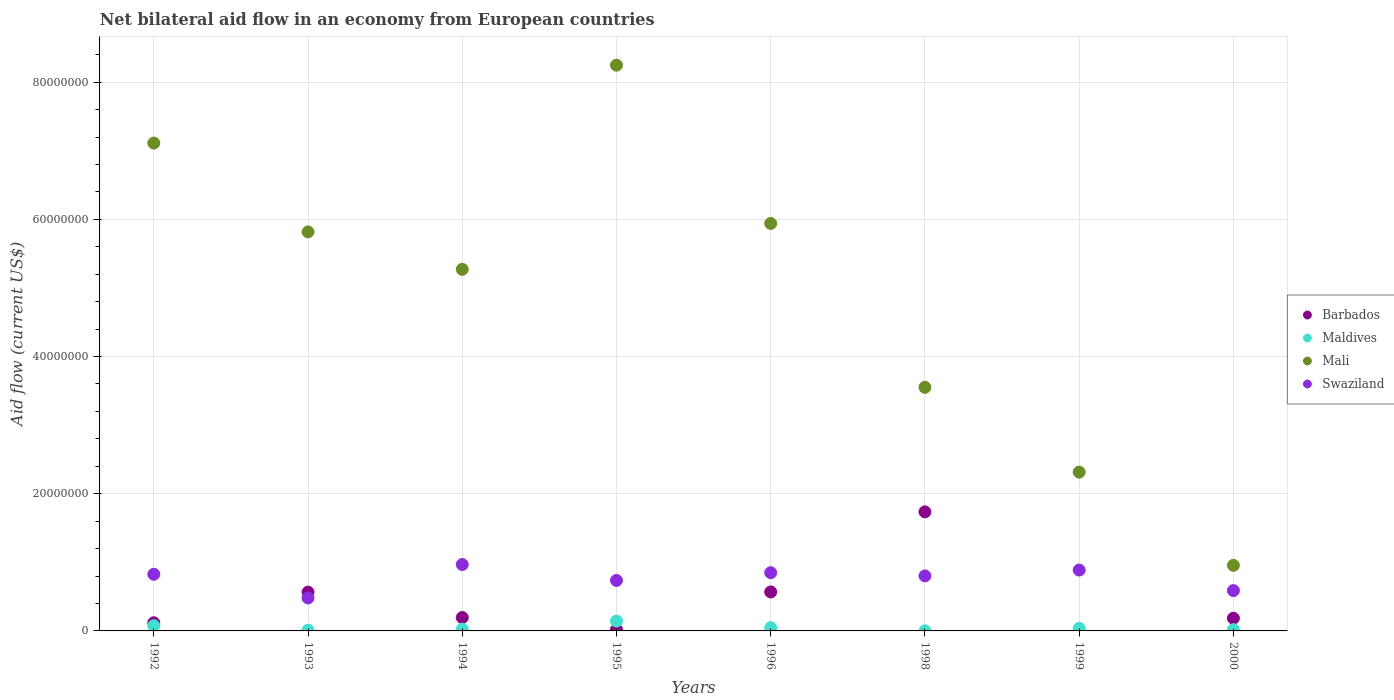How many different coloured dotlines are there?
Provide a succinct answer. 4. Is the number of dotlines equal to the number of legend labels?
Provide a succinct answer. No. What is the net bilateral aid flow in Maldives in 1995?
Offer a very short reply. 1.44e+06. Across all years, what is the maximum net bilateral aid flow in Mali?
Provide a succinct answer. 8.25e+07. Across all years, what is the minimum net bilateral aid flow in Mali?
Provide a succinct answer. 9.56e+06. In which year was the net bilateral aid flow in Maldives maximum?
Your response must be concise. 1995. What is the total net bilateral aid flow in Maldives in the graph?
Provide a succinct answer. 3.62e+06. What is the difference between the net bilateral aid flow in Swaziland in 1996 and that in 2000?
Offer a very short reply. 2.61e+06. What is the difference between the net bilateral aid flow in Mali in 1999 and the net bilateral aid flow in Barbados in 2000?
Ensure brevity in your answer.  2.13e+07. What is the average net bilateral aid flow in Swaziland per year?
Ensure brevity in your answer.  7.67e+06. In the year 1998, what is the difference between the net bilateral aid flow in Mali and net bilateral aid flow in Maldives?
Your answer should be compact. 3.55e+07. In how many years, is the net bilateral aid flow in Maldives greater than 72000000 US$?
Make the answer very short. 0. What is the ratio of the net bilateral aid flow in Swaziland in 1996 to that in 1998?
Ensure brevity in your answer.  1.06. Is the net bilateral aid flow in Swaziland in 1994 less than that in 2000?
Provide a short and direct response. No. What is the difference between the highest and the second highest net bilateral aid flow in Barbados?
Your answer should be very brief. 1.17e+07. What is the difference between the highest and the lowest net bilateral aid flow in Barbados?
Give a very brief answer. 1.74e+07. Is the sum of the net bilateral aid flow in Swaziland in 1998 and 2000 greater than the maximum net bilateral aid flow in Maldives across all years?
Keep it short and to the point. Yes. Is it the case that in every year, the sum of the net bilateral aid flow in Swaziland and net bilateral aid flow in Maldives  is greater than the net bilateral aid flow in Mali?
Provide a succinct answer. No. Does the net bilateral aid flow in Swaziland monotonically increase over the years?
Keep it short and to the point. No. Is the net bilateral aid flow in Mali strictly greater than the net bilateral aid flow in Swaziland over the years?
Offer a terse response. Yes. How many dotlines are there?
Your answer should be very brief. 4. Does the graph contain any zero values?
Your answer should be compact. Yes. Does the graph contain grids?
Your answer should be very brief. Yes. Where does the legend appear in the graph?
Offer a terse response. Center right. How many legend labels are there?
Ensure brevity in your answer.  4. How are the legend labels stacked?
Provide a succinct answer. Vertical. What is the title of the graph?
Your answer should be very brief. Net bilateral aid flow in an economy from European countries. What is the Aid flow (current US$) of Barbados in 1992?
Your response must be concise. 1.19e+06. What is the Aid flow (current US$) of Maldives in 1992?
Your response must be concise. 7.60e+05. What is the Aid flow (current US$) of Mali in 1992?
Give a very brief answer. 7.11e+07. What is the Aid flow (current US$) in Swaziland in 1992?
Offer a very short reply. 8.26e+06. What is the Aid flow (current US$) in Barbados in 1993?
Your answer should be very brief. 5.66e+06. What is the Aid flow (current US$) of Maldives in 1993?
Ensure brevity in your answer.  1.10e+05. What is the Aid flow (current US$) in Mali in 1993?
Your answer should be very brief. 5.82e+07. What is the Aid flow (current US$) of Swaziland in 1993?
Keep it short and to the point. 4.80e+06. What is the Aid flow (current US$) of Barbados in 1994?
Give a very brief answer. 1.95e+06. What is the Aid flow (current US$) in Maldives in 1994?
Offer a very short reply. 2.60e+05. What is the Aid flow (current US$) in Mali in 1994?
Provide a short and direct response. 5.27e+07. What is the Aid flow (current US$) in Swaziland in 1994?
Provide a short and direct response. 9.68e+06. What is the Aid flow (current US$) in Barbados in 1995?
Keep it short and to the point. 1.80e+05. What is the Aid flow (current US$) in Maldives in 1995?
Your response must be concise. 1.44e+06. What is the Aid flow (current US$) of Mali in 1995?
Provide a short and direct response. 8.25e+07. What is the Aid flow (current US$) in Swaziland in 1995?
Keep it short and to the point. 7.36e+06. What is the Aid flow (current US$) in Barbados in 1996?
Keep it short and to the point. 5.68e+06. What is the Aid flow (current US$) in Mali in 1996?
Provide a succinct answer. 5.94e+07. What is the Aid flow (current US$) in Swaziland in 1996?
Provide a succinct answer. 8.49e+06. What is the Aid flow (current US$) in Barbados in 1998?
Provide a succinct answer. 1.74e+07. What is the Aid flow (current US$) in Maldives in 1998?
Offer a terse response. 2.00e+04. What is the Aid flow (current US$) in Mali in 1998?
Make the answer very short. 3.55e+07. What is the Aid flow (current US$) of Swaziland in 1998?
Keep it short and to the point. 8.02e+06. What is the Aid flow (current US$) of Maldives in 1999?
Offer a very short reply. 3.70e+05. What is the Aid flow (current US$) of Mali in 1999?
Your answer should be very brief. 2.32e+07. What is the Aid flow (current US$) of Swaziland in 1999?
Give a very brief answer. 8.87e+06. What is the Aid flow (current US$) of Barbados in 2000?
Provide a succinct answer. 1.85e+06. What is the Aid flow (current US$) of Mali in 2000?
Make the answer very short. 9.56e+06. What is the Aid flow (current US$) in Swaziland in 2000?
Give a very brief answer. 5.88e+06. Across all years, what is the maximum Aid flow (current US$) of Barbados?
Give a very brief answer. 1.74e+07. Across all years, what is the maximum Aid flow (current US$) in Maldives?
Provide a succinct answer. 1.44e+06. Across all years, what is the maximum Aid flow (current US$) of Mali?
Make the answer very short. 8.25e+07. Across all years, what is the maximum Aid flow (current US$) in Swaziland?
Provide a short and direct response. 9.68e+06. Across all years, what is the minimum Aid flow (current US$) of Mali?
Provide a succinct answer. 9.56e+06. Across all years, what is the minimum Aid flow (current US$) in Swaziland?
Provide a succinct answer. 4.80e+06. What is the total Aid flow (current US$) in Barbados in the graph?
Your answer should be compact. 3.39e+07. What is the total Aid flow (current US$) in Maldives in the graph?
Keep it short and to the point. 3.62e+06. What is the total Aid flow (current US$) in Mali in the graph?
Your response must be concise. 3.92e+08. What is the total Aid flow (current US$) of Swaziland in the graph?
Your answer should be very brief. 6.14e+07. What is the difference between the Aid flow (current US$) of Barbados in 1992 and that in 1993?
Offer a terse response. -4.47e+06. What is the difference between the Aid flow (current US$) in Maldives in 1992 and that in 1993?
Make the answer very short. 6.50e+05. What is the difference between the Aid flow (current US$) in Mali in 1992 and that in 1993?
Keep it short and to the point. 1.30e+07. What is the difference between the Aid flow (current US$) in Swaziland in 1992 and that in 1993?
Offer a terse response. 3.46e+06. What is the difference between the Aid flow (current US$) of Barbados in 1992 and that in 1994?
Ensure brevity in your answer.  -7.60e+05. What is the difference between the Aid flow (current US$) in Maldives in 1992 and that in 1994?
Give a very brief answer. 5.00e+05. What is the difference between the Aid flow (current US$) of Mali in 1992 and that in 1994?
Make the answer very short. 1.84e+07. What is the difference between the Aid flow (current US$) in Swaziland in 1992 and that in 1994?
Provide a succinct answer. -1.42e+06. What is the difference between the Aid flow (current US$) of Barbados in 1992 and that in 1995?
Ensure brevity in your answer.  1.01e+06. What is the difference between the Aid flow (current US$) of Maldives in 1992 and that in 1995?
Offer a very short reply. -6.80e+05. What is the difference between the Aid flow (current US$) of Mali in 1992 and that in 1995?
Your response must be concise. -1.14e+07. What is the difference between the Aid flow (current US$) in Barbados in 1992 and that in 1996?
Keep it short and to the point. -4.49e+06. What is the difference between the Aid flow (current US$) of Maldives in 1992 and that in 1996?
Offer a terse response. 2.80e+05. What is the difference between the Aid flow (current US$) of Mali in 1992 and that in 1996?
Ensure brevity in your answer.  1.17e+07. What is the difference between the Aid flow (current US$) of Swaziland in 1992 and that in 1996?
Keep it short and to the point. -2.30e+05. What is the difference between the Aid flow (current US$) of Barbados in 1992 and that in 1998?
Give a very brief answer. -1.62e+07. What is the difference between the Aid flow (current US$) in Maldives in 1992 and that in 1998?
Make the answer very short. 7.40e+05. What is the difference between the Aid flow (current US$) of Mali in 1992 and that in 1998?
Ensure brevity in your answer.  3.56e+07. What is the difference between the Aid flow (current US$) of Maldives in 1992 and that in 1999?
Keep it short and to the point. 3.90e+05. What is the difference between the Aid flow (current US$) in Mali in 1992 and that in 1999?
Offer a very short reply. 4.80e+07. What is the difference between the Aid flow (current US$) in Swaziland in 1992 and that in 1999?
Keep it short and to the point. -6.10e+05. What is the difference between the Aid flow (current US$) of Barbados in 1992 and that in 2000?
Give a very brief answer. -6.60e+05. What is the difference between the Aid flow (current US$) in Maldives in 1992 and that in 2000?
Offer a terse response. 5.80e+05. What is the difference between the Aid flow (current US$) of Mali in 1992 and that in 2000?
Your response must be concise. 6.16e+07. What is the difference between the Aid flow (current US$) of Swaziland in 1992 and that in 2000?
Your answer should be very brief. 2.38e+06. What is the difference between the Aid flow (current US$) in Barbados in 1993 and that in 1994?
Your answer should be compact. 3.71e+06. What is the difference between the Aid flow (current US$) in Mali in 1993 and that in 1994?
Provide a short and direct response. 5.46e+06. What is the difference between the Aid flow (current US$) in Swaziland in 1993 and that in 1994?
Your answer should be very brief. -4.88e+06. What is the difference between the Aid flow (current US$) in Barbados in 1993 and that in 1995?
Offer a terse response. 5.48e+06. What is the difference between the Aid flow (current US$) of Maldives in 1993 and that in 1995?
Your answer should be very brief. -1.33e+06. What is the difference between the Aid flow (current US$) in Mali in 1993 and that in 1995?
Ensure brevity in your answer.  -2.43e+07. What is the difference between the Aid flow (current US$) of Swaziland in 1993 and that in 1995?
Keep it short and to the point. -2.56e+06. What is the difference between the Aid flow (current US$) in Barbados in 1993 and that in 1996?
Give a very brief answer. -2.00e+04. What is the difference between the Aid flow (current US$) in Maldives in 1993 and that in 1996?
Keep it short and to the point. -3.70e+05. What is the difference between the Aid flow (current US$) in Mali in 1993 and that in 1996?
Your answer should be compact. -1.23e+06. What is the difference between the Aid flow (current US$) of Swaziland in 1993 and that in 1996?
Offer a terse response. -3.69e+06. What is the difference between the Aid flow (current US$) in Barbados in 1993 and that in 1998?
Your response must be concise. -1.17e+07. What is the difference between the Aid flow (current US$) of Mali in 1993 and that in 1998?
Ensure brevity in your answer.  2.27e+07. What is the difference between the Aid flow (current US$) in Swaziland in 1993 and that in 1998?
Your answer should be very brief. -3.22e+06. What is the difference between the Aid flow (current US$) of Mali in 1993 and that in 1999?
Provide a short and direct response. 3.50e+07. What is the difference between the Aid flow (current US$) of Swaziland in 1993 and that in 1999?
Provide a succinct answer. -4.07e+06. What is the difference between the Aid flow (current US$) of Barbados in 1993 and that in 2000?
Offer a very short reply. 3.81e+06. What is the difference between the Aid flow (current US$) in Maldives in 1993 and that in 2000?
Offer a terse response. -7.00e+04. What is the difference between the Aid flow (current US$) of Mali in 1993 and that in 2000?
Your answer should be compact. 4.86e+07. What is the difference between the Aid flow (current US$) in Swaziland in 1993 and that in 2000?
Your response must be concise. -1.08e+06. What is the difference between the Aid flow (current US$) in Barbados in 1994 and that in 1995?
Offer a very short reply. 1.77e+06. What is the difference between the Aid flow (current US$) of Maldives in 1994 and that in 1995?
Offer a terse response. -1.18e+06. What is the difference between the Aid flow (current US$) of Mali in 1994 and that in 1995?
Your answer should be compact. -2.98e+07. What is the difference between the Aid flow (current US$) in Swaziland in 1994 and that in 1995?
Provide a short and direct response. 2.32e+06. What is the difference between the Aid flow (current US$) of Barbados in 1994 and that in 1996?
Your answer should be very brief. -3.73e+06. What is the difference between the Aid flow (current US$) in Mali in 1994 and that in 1996?
Your response must be concise. -6.69e+06. What is the difference between the Aid flow (current US$) in Swaziland in 1994 and that in 1996?
Keep it short and to the point. 1.19e+06. What is the difference between the Aid flow (current US$) of Barbados in 1994 and that in 1998?
Ensure brevity in your answer.  -1.54e+07. What is the difference between the Aid flow (current US$) in Maldives in 1994 and that in 1998?
Provide a short and direct response. 2.40e+05. What is the difference between the Aid flow (current US$) of Mali in 1994 and that in 1998?
Give a very brief answer. 1.72e+07. What is the difference between the Aid flow (current US$) of Swaziland in 1994 and that in 1998?
Provide a succinct answer. 1.66e+06. What is the difference between the Aid flow (current US$) in Mali in 1994 and that in 1999?
Your answer should be compact. 2.96e+07. What is the difference between the Aid flow (current US$) in Swaziland in 1994 and that in 1999?
Provide a short and direct response. 8.10e+05. What is the difference between the Aid flow (current US$) in Mali in 1994 and that in 2000?
Offer a very short reply. 4.32e+07. What is the difference between the Aid flow (current US$) of Swaziland in 1994 and that in 2000?
Provide a succinct answer. 3.80e+06. What is the difference between the Aid flow (current US$) of Barbados in 1995 and that in 1996?
Your response must be concise. -5.50e+06. What is the difference between the Aid flow (current US$) of Maldives in 1995 and that in 1996?
Your answer should be compact. 9.60e+05. What is the difference between the Aid flow (current US$) in Mali in 1995 and that in 1996?
Provide a short and direct response. 2.31e+07. What is the difference between the Aid flow (current US$) of Swaziland in 1995 and that in 1996?
Provide a succinct answer. -1.13e+06. What is the difference between the Aid flow (current US$) of Barbados in 1995 and that in 1998?
Your answer should be very brief. -1.72e+07. What is the difference between the Aid flow (current US$) in Maldives in 1995 and that in 1998?
Your answer should be compact. 1.42e+06. What is the difference between the Aid flow (current US$) in Mali in 1995 and that in 1998?
Offer a terse response. 4.70e+07. What is the difference between the Aid flow (current US$) in Swaziland in 1995 and that in 1998?
Make the answer very short. -6.60e+05. What is the difference between the Aid flow (current US$) in Maldives in 1995 and that in 1999?
Provide a succinct answer. 1.07e+06. What is the difference between the Aid flow (current US$) in Mali in 1995 and that in 1999?
Ensure brevity in your answer.  5.93e+07. What is the difference between the Aid flow (current US$) of Swaziland in 1995 and that in 1999?
Offer a very short reply. -1.51e+06. What is the difference between the Aid flow (current US$) of Barbados in 1995 and that in 2000?
Keep it short and to the point. -1.67e+06. What is the difference between the Aid flow (current US$) of Maldives in 1995 and that in 2000?
Your answer should be compact. 1.26e+06. What is the difference between the Aid flow (current US$) in Mali in 1995 and that in 2000?
Your answer should be compact. 7.29e+07. What is the difference between the Aid flow (current US$) of Swaziland in 1995 and that in 2000?
Make the answer very short. 1.48e+06. What is the difference between the Aid flow (current US$) of Barbados in 1996 and that in 1998?
Your response must be concise. -1.17e+07. What is the difference between the Aid flow (current US$) in Maldives in 1996 and that in 1998?
Give a very brief answer. 4.60e+05. What is the difference between the Aid flow (current US$) in Mali in 1996 and that in 1998?
Your answer should be compact. 2.39e+07. What is the difference between the Aid flow (current US$) in Maldives in 1996 and that in 1999?
Provide a short and direct response. 1.10e+05. What is the difference between the Aid flow (current US$) in Mali in 1996 and that in 1999?
Provide a short and direct response. 3.62e+07. What is the difference between the Aid flow (current US$) of Swaziland in 1996 and that in 1999?
Give a very brief answer. -3.80e+05. What is the difference between the Aid flow (current US$) in Barbados in 1996 and that in 2000?
Give a very brief answer. 3.83e+06. What is the difference between the Aid flow (current US$) of Mali in 1996 and that in 2000?
Your answer should be compact. 4.98e+07. What is the difference between the Aid flow (current US$) of Swaziland in 1996 and that in 2000?
Offer a terse response. 2.61e+06. What is the difference between the Aid flow (current US$) in Maldives in 1998 and that in 1999?
Your answer should be very brief. -3.50e+05. What is the difference between the Aid flow (current US$) in Mali in 1998 and that in 1999?
Give a very brief answer. 1.24e+07. What is the difference between the Aid flow (current US$) of Swaziland in 1998 and that in 1999?
Your response must be concise. -8.50e+05. What is the difference between the Aid flow (current US$) in Barbados in 1998 and that in 2000?
Provide a succinct answer. 1.55e+07. What is the difference between the Aid flow (current US$) of Maldives in 1998 and that in 2000?
Your answer should be very brief. -1.60e+05. What is the difference between the Aid flow (current US$) in Mali in 1998 and that in 2000?
Make the answer very short. 2.60e+07. What is the difference between the Aid flow (current US$) in Swaziland in 1998 and that in 2000?
Make the answer very short. 2.14e+06. What is the difference between the Aid flow (current US$) of Mali in 1999 and that in 2000?
Provide a short and direct response. 1.36e+07. What is the difference between the Aid flow (current US$) in Swaziland in 1999 and that in 2000?
Keep it short and to the point. 2.99e+06. What is the difference between the Aid flow (current US$) in Barbados in 1992 and the Aid flow (current US$) in Maldives in 1993?
Provide a succinct answer. 1.08e+06. What is the difference between the Aid flow (current US$) in Barbados in 1992 and the Aid flow (current US$) in Mali in 1993?
Make the answer very short. -5.70e+07. What is the difference between the Aid flow (current US$) in Barbados in 1992 and the Aid flow (current US$) in Swaziland in 1993?
Provide a short and direct response. -3.61e+06. What is the difference between the Aid flow (current US$) of Maldives in 1992 and the Aid flow (current US$) of Mali in 1993?
Make the answer very short. -5.74e+07. What is the difference between the Aid flow (current US$) of Maldives in 1992 and the Aid flow (current US$) of Swaziland in 1993?
Your answer should be compact. -4.04e+06. What is the difference between the Aid flow (current US$) in Mali in 1992 and the Aid flow (current US$) in Swaziland in 1993?
Ensure brevity in your answer.  6.63e+07. What is the difference between the Aid flow (current US$) of Barbados in 1992 and the Aid flow (current US$) of Maldives in 1994?
Provide a succinct answer. 9.30e+05. What is the difference between the Aid flow (current US$) in Barbados in 1992 and the Aid flow (current US$) in Mali in 1994?
Provide a short and direct response. -5.15e+07. What is the difference between the Aid flow (current US$) of Barbados in 1992 and the Aid flow (current US$) of Swaziland in 1994?
Offer a terse response. -8.49e+06. What is the difference between the Aid flow (current US$) of Maldives in 1992 and the Aid flow (current US$) of Mali in 1994?
Give a very brief answer. -5.20e+07. What is the difference between the Aid flow (current US$) in Maldives in 1992 and the Aid flow (current US$) in Swaziland in 1994?
Provide a short and direct response. -8.92e+06. What is the difference between the Aid flow (current US$) in Mali in 1992 and the Aid flow (current US$) in Swaziland in 1994?
Offer a terse response. 6.14e+07. What is the difference between the Aid flow (current US$) in Barbados in 1992 and the Aid flow (current US$) in Maldives in 1995?
Give a very brief answer. -2.50e+05. What is the difference between the Aid flow (current US$) of Barbados in 1992 and the Aid flow (current US$) of Mali in 1995?
Offer a terse response. -8.13e+07. What is the difference between the Aid flow (current US$) in Barbados in 1992 and the Aid flow (current US$) in Swaziland in 1995?
Keep it short and to the point. -6.17e+06. What is the difference between the Aid flow (current US$) of Maldives in 1992 and the Aid flow (current US$) of Mali in 1995?
Offer a very short reply. -8.17e+07. What is the difference between the Aid flow (current US$) of Maldives in 1992 and the Aid flow (current US$) of Swaziland in 1995?
Offer a very short reply. -6.60e+06. What is the difference between the Aid flow (current US$) in Mali in 1992 and the Aid flow (current US$) in Swaziland in 1995?
Offer a very short reply. 6.38e+07. What is the difference between the Aid flow (current US$) of Barbados in 1992 and the Aid flow (current US$) of Maldives in 1996?
Your answer should be very brief. 7.10e+05. What is the difference between the Aid flow (current US$) in Barbados in 1992 and the Aid flow (current US$) in Mali in 1996?
Make the answer very short. -5.82e+07. What is the difference between the Aid flow (current US$) of Barbados in 1992 and the Aid flow (current US$) of Swaziland in 1996?
Provide a short and direct response. -7.30e+06. What is the difference between the Aid flow (current US$) of Maldives in 1992 and the Aid flow (current US$) of Mali in 1996?
Give a very brief answer. -5.86e+07. What is the difference between the Aid flow (current US$) of Maldives in 1992 and the Aid flow (current US$) of Swaziland in 1996?
Provide a succinct answer. -7.73e+06. What is the difference between the Aid flow (current US$) of Mali in 1992 and the Aid flow (current US$) of Swaziland in 1996?
Your response must be concise. 6.26e+07. What is the difference between the Aid flow (current US$) in Barbados in 1992 and the Aid flow (current US$) in Maldives in 1998?
Make the answer very short. 1.17e+06. What is the difference between the Aid flow (current US$) in Barbados in 1992 and the Aid flow (current US$) in Mali in 1998?
Provide a succinct answer. -3.43e+07. What is the difference between the Aid flow (current US$) of Barbados in 1992 and the Aid flow (current US$) of Swaziland in 1998?
Provide a short and direct response. -6.83e+06. What is the difference between the Aid flow (current US$) of Maldives in 1992 and the Aid flow (current US$) of Mali in 1998?
Offer a terse response. -3.48e+07. What is the difference between the Aid flow (current US$) in Maldives in 1992 and the Aid flow (current US$) in Swaziland in 1998?
Provide a short and direct response. -7.26e+06. What is the difference between the Aid flow (current US$) in Mali in 1992 and the Aid flow (current US$) in Swaziland in 1998?
Keep it short and to the point. 6.31e+07. What is the difference between the Aid flow (current US$) in Barbados in 1992 and the Aid flow (current US$) in Maldives in 1999?
Give a very brief answer. 8.20e+05. What is the difference between the Aid flow (current US$) in Barbados in 1992 and the Aid flow (current US$) in Mali in 1999?
Give a very brief answer. -2.20e+07. What is the difference between the Aid flow (current US$) in Barbados in 1992 and the Aid flow (current US$) in Swaziland in 1999?
Provide a succinct answer. -7.68e+06. What is the difference between the Aid flow (current US$) in Maldives in 1992 and the Aid flow (current US$) in Mali in 1999?
Keep it short and to the point. -2.24e+07. What is the difference between the Aid flow (current US$) in Maldives in 1992 and the Aid flow (current US$) in Swaziland in 1999?
Ensure brevity in your answer.  -8.11e+06. What is the difference between the Aid flow (current US$) in Mali in 1992 and the Aid flow (current US$) in Swaziland in 1999?
Ensure brevity in your answer.  6.22e+07. What is the difference between the Aid flow (current US$) in Barbados in 1992 and the Aid flow (current US$) in Maldives in 2000?
Provide a short and direct response. 1.01e+06. What is the difference between the Aid flow (current US$) of Barbados in 1992 and the Aid flow (current US$) of Mali in 2000?
Your response must be concise. -8.37e+06. What is the difference between the Aid flow (current US$) in Barbados in 1992 and the Aid flow (current US$) in Swaziland in 2000?
Your answer should be compact. -4.69e+06. What is the difference between the Aid flow (current US$) in Maldives in 1992 and the Aid flow (current US$) in Mali in 2000?
Your answer should be compact. -8.80e+06. What is the difference between the Aid flow (current US$) in Maldives in 1992 and the Aid flow (current US$) in Swaziland in 2000?
Provide a succinct answer. -5.12e+06. What is the difference between the Aid flow (current US$) in Mali in 1992 and the Aid flow (current US$) in Swaziland in 2000?
Offer a terse response. 6.52e+07. What is the difference between the Aid flow (current US$) of Barbados in 1993 and the Aid flow (current US$) of Maldives in 1994?
Provide a short and direct response. 5.40e+06. What is the difference between the Aid flow (current US$) in Barbados in 1993 and the Aid flow (current US$) in Mali in 1994?
Give a very brief answer. -4.70e+07. What is the difference between the Aid flow (current US$) in Barbados in 1993 and the Aid flow (current US$) in Swaziland in 1994?
Provide a succinct answer. -4.02e+06. What is the difference between the Aid flow (current US$) in Maldives in 1993 and the Aid flow (current US$) in Mali in 1994?
Provide a short and direct response. -5.26e+07. What is the difference between the Aid flow (current US$) of Maldives in 1993 and the Aid flow (current US$) of Swaziland in 1994?
Make the answer very short. -9.57e+06. What is the difference between the Aid flow (current US$) in Mali in 1993 and the Aid flow (current US$) in Swaziland in 1994?
Ensure brevity in your answer.  4.85e+07. What is the difference between the Aid flow (current US$) in Barbados in 1993 and the Aid flow (current US$) in Maldives in 1995?
Your answer should be compact. 4.22e+06. What is the difference between the Aid flow (current US$) of Barbados in 1993 and the Aid flow (current US$) of Mali in 1995?
Offer a terse response. -7.68e+07. What is the difference between the Aid flow (current US$) of Barbados in 1993 and the Aid flow (current US$) of Swaziland in 1995?
Provide a short and direct response. -1.70e+06. What is the difference between the Aid flow (current US$) in Maldives in 1993 and the Aid flow (current US$) in Mali in 1995?
Your answer should be compact. -8.24e+07. What is the difference between the Aid flow (current US$) in Maldives in 1993 and the Aid flow (current US$) in Swaziland in 1995?
Provide a short and direct response. -7.25e+06. What is the difference between the Aid flow (current US$) in Mali in 1993 and the Aid flow (current US$) in Swaziland in 1995?
Make the answer very short. 5.08e+07. What is the difference between the Aid flow (current US$) in Barbados in 1993 and the Aid flow (current US$) in Maldives in 1996?
Your response must be concise. 5.18e+06. What is the difference between the Aid flow (current US$) in Barbados in 1993 and the Aid flow (current US$) in Mali in 1996?
Ensure brevity in your answer.  -5.37e+07. What is the difference between the Aid flow (current US$) in Barbados in 1993 and the Aid flow (current US$) in Swaziland in 1996?
Keep it short and to the point. -2.83e+06. What is the difference between the Aid flow (current US$) of Maldives in 1993 and the Aid flow (current US$) of Mali in 1996?
Your answer should be compact. -5.93e+07. What is the difference between the Aid flow (current US$) of Maldives in 1993 and the Aid flow (current US$) of Swaziland in 1996?
Offer a terse response. -8.38e+06. What is the difference between the Aid flow (current US$) in Mali in 1993 and the Aid flow (current US$) in Swaziland in 1996?
Your answer should be very brief. 4.97e+07. What is the difference between the Aid flow (current US$) of Barbados in 1993 and the Aid flow (current US$) of Maldives in 1998?
Provide a short and direct response. 5.64e+06. What is the difference between the Aid flow (current US$) in Barbados in 1993 and the Aid flow (current US$) in Mali in 1998?
Offer a very short reply. -2.98e+07. What is the difference between the Aid flow (current US$) in Barbados in 1993 and the Aid flow (current US$) in Swaziland in 1998?
Offer a very short reply. -2.36e+06. What is the difference between the Aid flow (current US$) of Maldives in 1993 and the Aid flow (current US$) of Mali in 1998?
Offer a terse response. -3.54e+07. What is the difference between the Aid flow (current US$) of Maldives in 1993 and the Aid flow (current US$) of Swaziland in 1998?
Offer a very short reply. -7.91e+06. What is the difference between the Aid flow (current US$) of Mali in 1993 and the Aid flow (current US$) of Swaziland in 1998?
Provide a succinct answer. 5.02e+07. What is the difference between the Aid flow (current US$) in Barbados in 1993 and the Aid flow (current US$) in Maldives in 1999?
Offer a terse response. 5.29e+06. What is the difference between the Aid flow (current US$) in Barbados in 1993 and the Aid flow (current US$) in Mali in 1999?
Your answer should be very brief. -1.75e+07. What is the difference between the Aid flow (current US$) of Barbados in 1993 and the Aid flow (current US$) of Swaziland in 1999?
Provide a succinct answer. -3.21e+06. What is the difference between the Aid flow (current US$) in Maldives in 1993 and the Aid flow (current US$) in Mali in 1999?
Your answer should be very brief. -2.30e+07. What is the difference between the Aid flow (current US$) in Maldives in 1993 and the Aid flow (current US$) in Swaziland in 1999?
Give a very brief answer. -8.76e+06. What is the difference between the Aid flow (current US$) of Mali in 1993 and the Aid flow (current US$) of Swaziland in 1999?
Give a very brief answer. 4.93e+07. What is the difference between the Aid flow (current US$) of Barbados in 1993 and the Aid flow (current US$) of Maldives in 2000?
Provide a short and direct response. 5.48e+06. What is the difference between the Aid flow (current US$) of Barbados in 1993 and the Aid flow (current US$) of Mali in 2000?
Offer a terse response. -3.90e+06. What is the difference between the Aid flow (current US$) of Maldives in 1993 and the Aid flow (current US$) of Mali in 2000?
Ensure brevity in your answer.  -9.45e+06. What is the difference between the Aid flow (current US$) of Maldives in 1993 and the Aid flow (current US$) of Swaziland in 2000?
Offer a terse response. -5.77e+06. What is the difference between the Aid flow (current US$) in Mali in 1993 and the Aid flow (current US$) in Swaziland in 2000?
Ensure brevity in your answer.  5.23e+07. What is the difference between the Aid flow (current US$) of Barbados in 1994 and the Aid flow (current US$) of Maldives in 1995?
Offer a very short reply. 5.10e+05. What is the difference between the Aid flow (current US$) of Barbados in 1994 and the Aid flow (current US$) of Mali in 1995?
Your answer should be compact. -8.05e+07. What is the difference between the Aid flow (current US$) in Barbados in 1994 and the Aid flow (current US$) in Swaziland in 1995?
Give a very brief answer. -5.41e+06. What is the difference between the Aid flow (current US$) of Maldives in 1994 and the Aid flow (current US$) of Mali in 1995?
Provide a succinct answer. -8.22e+07. What is the difference between the Aid flow (current US$) of Maldives in 1994 and the Aid flow (current US$) of Swaziland in 1995?
Provide a short and direct response. -7.10e+06. What is the difference between the Aid flow (current US$) in Mali in 1994 and the Aid flow (current US$) in Swaziland in 1995?
Offer a terse response. 4.54e+07. What is the difference between the Aid flow (current US$) of Barbados in 1994 and the Aid flow (current US$) of Maldives in 1996?
Your answer should be very brief. 1.47e+06. What is the difference between the Aid flow (current US$) of Barbados in 1994 and the Aid flow (current US$) of Mali in 1996?
Give a very brief answer. -5.74e+07. What is the difference between the Aid flow (current US$) in Barbados in 1994 and the Aid flow (current US$) in Swaziland in 1996?
Ensure brevity in your answer.  -6.54e+06. What is the difference between the Aid flow (current US$) in Maldives in 1994 and the Aid flow (current US$) in Mali in 1996?
Provide a succinct answer. -5.91e+07. What is the difference between the Aid flow (current US$) of Maldives in 1994 and the Aid flow (current US$) of Swaziland in 1996?
Your response must be concise. -8.23e+06. What is the difference between the Aid flow (current US$) of Mali in 1994 and the Aid flow (current US$) of Swaziland in 1996?
Keep it short and to the point. 4.42e+07. What is the difference between the Aid flow (current US$) in Barbados in 1994 and the Aid flow (current US$) in Maldives in 1998?
Give a very brief answer. 1.93e+06. What is the difference between the Aid flow (current US$) in Barbados in 1994 and the Aid flow (current US$) in Mali in 1998?
Your answer should be compact. -3.36e+07. What is the difference between the Aid flow (current US$) of Barbados in 1994 and the Aid flow (current US$) of Swaziland in 1998?
Your answer should be very brief. -6.07e+06. What is the difference between the Aid flow (current US$) of Maldives in 1994 and the Aid flow (current US$) of Mali in 1998?
Your answer should be compact. -3.52e+07. What is the difference between the Aid flow (current US$) of Maldives in 1994 and the Aid flow (current US$) of Swaziland in 1998?
Your answer should be very brief. -7.76e+06. What is the difference between the Aid flow (current US$) of Mali in 1994 and the Aid flow (current US$) of Swaziland in 1998?
Offer a very short reply. 4.47e+07. What is the difference between the Aid flow (current US$) in Barbados in 1994 and the Aid flow (current US$) in Maldives in 1999?
Your answer should be compact. 1.58e+06. What is the difference between the Aid flow (current US$) of Barbados in 1994 and the Aid flow (current US$) of Mali in 1999?
Ensure brevity in your answer.  -2.12e+07. What is the difference between the Aid flow (current US$) in Barbados in 1994 and the Aid flow (current US$) in Swaziland in 1999?
Your answer should be very brief. -6.92e+06. What is the difference between the Aid flow (current US$) in Maldives in 1994 and the Aid flow (current US$) in Mali in 1999?
Give a very brief answer. -2.29e+07. What is the difference between the Aid flow (current US$) in Maldives in 1994 and the Aid flow (current US$) in Swaziland in 1999?
Keep it short and to the point. -8.61e+06. What is the difference between the Aid flow (current US$) of Mali in 1994 and the Aid flow (current US$) of Swaziland in 1999?
Provide a succinct answer. 4.38e+07. What is the difference between the Aid flow (current US$) of Barbados in 1994 and the Aid flow (current US$) of Maldives in 2000?
Give a very brief answer. 1.77e+06. What is the difference between the Aid flow (current US$) of Barbados in 1994 and the Aid flow (current US$) of Mali in 2000?
Provide a succinct answer. -7.61e+06. What is the difference between the Aid flow (current US$) of Barbados in 1994 and the Aid flow (current US$) of Swaziland in 2000?
Your response must be concise. -3.93e+06. What is the difference between the Aid flow (current US$) of Maldives in 1994 and the Aid flow (current US$) of Mali in 2000?
Provide a short and direct response. -9.30e+06. What is the difference between the Aid flow (current US$) of Maldives in 1994 and the Aid flow (current US$) of Swaziland in 2000?
Offer a terse response. -5.62e+06. What is the difference between the Aid flow (current US$) of Mali in 1994 and the Aid flow (current US$) of Swaziland in 2000?
Give a very brief answer. 4.68e+07. What is the difference between the Aid flow (current US$) in Barbados in 1995 and the Aid flow (current US$) in Mali in 1996?
Your answer should be very brief. -5.92e+07. What is the difference between the Aid flow (current US$) of Barbados in 1995 and the Aid flow (current US$) of Swaziland in 1996?
Offer a terse response. -8.31e+06. What is the difference between the Aid flow (current US$) of Maldives in 1995 and the Aid flow (current US$) of Mali in 1996?
Give a very brief answer. -5.80e+07. What is the difference between the Aid flow (current US$) in Maldives in 1995 and the Aid flow (current US$) in Swaziland in 1996?
Keep it short and to the point. -7.05e+06. What is the difference between the Aid flow (current US$) in Mali in 1995 and the Aid flow (current US$) in Swaziland in 1996?
Your answer should be compact. 7.40e+07. What is the difference between the Aid flow (current US$) in Barbados in 1995 and the Aid flow (current US$) in Maldives in 1998?
Keep it short and to the point. 1.60e+05. What is the difference between the Aid flow (current US$) of Barbados in 1995 and the Aid flow (current US$) of Mali in 1998?
Your answer should be very brief. -3.53e+07. What is the difference between the Aid flow (current US$) of Barbados in 1995 and the Aid flow (current US$) of Swaziland in 1998?
Offer a very short reply. -7.84e+06. What is the difference between the Aid flow (current US$) in Maldives in 1995 and the Aid flow (current US$) in Mali in 1998?
Provide a succinct answer. -3.41e+07. What is the difference between the Aid flow (current US$) of Maldives in 1995 and the Aid flow (current US$) of Swaziland in 1998?
Provide a short and direct response. -6.58e+06. What is the difference between the Aid flow (current US$) in Mali in 1995 and the Aid flow (current US$) in Swaziland in 1998?
Your answer should be compact. 7.44e+07. What is the difference between the Aid flow (current US$) of Barbados in 1995 and the Aid flow (current US$) of Mali in 1999?
Keep it short and to the point. -2.30e+07. What is the difference between the Aid flow (current US$) of Barbados in 1995 and the Aid flow (current US$) of Swaziland in 1999?
Provide a short and direct response. -8.69e+06. What is the difference between the Aid flow (current US$) of Maldives in 1995 and the Aid flow (current US$) of Mali in 1999?
Provide a short and direct response. -2.17e+07. What is the difference between the Aid flow (current US$) in Maldives in 1995 and the Aid flow (current US$) in Swaziland in 1999?
Ensure brevity in your answer.  -7.43e+06. What is the difference between the Aid flow (current US$) of Mali in 1995 and the Aid flow (current US$) of Swaziland in 1999?
Provide a short and direct response. 7.36e+07. What is the difference between the Aid flow (current US$) in Barbados in 1995 and the Aid flow (current US$) in Mali in 2000?
Offer a terse response. -9.38e+06. What is the difference between the Aid flow (current US$) of Barbados in 1995 and the Aid flow (current US$) of Swaziland in 2000?
Your answer should be compact. -5.70e+06. What is the difference between the Aid flow (current US$) in Maldives in 1995 and the Aid flow (current US$) in Mali in 2000?
Give a very brief answer. -8.12e+06. What is the difference between the Aid flow (current US$) of Maldives in 1995 and the Aid flow (current US$) of Swaziland in 2000?
Ensure brevity in your answer.  -4.44e+06. What is the difference between the Aid flow (current US$) in Mali in 1995 and the Aid flow (current US$) in Swaziland in 2000?
Provide a short and direct response. 7.66e+07. What is the difference between the Aid flow (current US$) of Barbados in 1996 and the Aid flow (current US$) of Maldives in 1998?
Your answer should be very brief. 5.66e+06. What is the difference between the Aid flow (current US$) of Barbados in 1996 and the Aid flow (current US$) of Mali in 1998?
Your answer should be compact. -2.98e+07. What is the difference between the Aid flow (current US$) of Barbados in 1996 and the Aid flow (current US$) of Swaziland in 1998?
Keep it short and to the point. -2.34e+06. What is the difference between the Aid flow (current US$) in Maldives in 1996 and the Aid flow (current US$) in Mali in 1998?
Make the answer very short. -3.50e+07. What is the difference between the Aid flow (current US$) of Maldives in 1996 and the Aid flow (current US$) of Swaziland in 1998?
Your response must be concise. -7.54e+06. What is the difference between the Aid flow (current US$) in Mali in 1996 and the Aid flow (current US$) in Swaziland in 1998?
Make the answer very short. 5.14e+07. What is the difference between the Aid flow (current US$) in Barbados in 1996 and the Aid flow (current US$) in Maldives in 1999?
Make the answer very short. 5.31e+06. What is the difference between the Aid flow (current US$) of Barbados in 1996 and the Aid flow (current US$) of Mali in 1999?
Ensure brevity in your answer.  -1.75e+07. What is the difference between the Aid flow (current US$) in Barbados in 1996 and the Aid flow (current US$) in Swaziland in 1999?
Make the answer very short. -3.19e+06. What is the difference between the Aid flow (current US$) of Maldives in 1996 and the Aid flow (current US$) of Mali in 1999?
Your answer should be compact. -2.27e+07. What is the difference between the Aid flow (current US$) of Maldives in 1996 and the Aid flow (current US$) of Swaziland in 1999?
Make the answer very short. -8.39e+06. What is the difference between the Aid flow (current US$) in Mali in 1996 and the Aid flow (current US$) in Swaziland in 1999?
Make the answer very short. 5.05e+07. What is the difference between the Aid flow (current US$) of Barbados in 1996 and the Aid flow (current US$) of Maldives in 2000?
Give a very brief answer. 5.50e+06. What is the difference between the Aid flow (current US$) in Barbados in 1996 and the Aid flow (current US$) in Mali in 2000?
Your response must be concise. -3.88e+06. What is the difference between the Aid flow (current US$) of Maldives in 1996 and the Aid flow (current US$) of Mali in 2000?
Make the answer very short. -9.08e+06. What is the difference between the Aid flow (current US$) of Maldives in 1996 and the Aid flow (current US$) of Swaziland in 2000?
Offer a very short reply. -5.40e+06. What is the difference between the Aid flow (current US$) of Mali in 1996 and the Aid flow (current US$) of Swaziland in 2000?
Give a very brief answer. 5.35e+07. What is the difference between the Aid flow (current US$) of Barbados in 1998 and the Aid flow (current US$) of Maldives in 1999?
Your answer should be very brief. 1.70e+07. What is the difference between the Aid flow (current US$) of Barbados in 1998 and the Aid flow (current US$) of Mali in 1999?
Ensure brevity in your answer.  -5.79e+06. What is the difference between the Aid flow (current US$) in Barbados in 1998 and the Aid flow (current US$) in Swaziland in 1999?
Provide a short and direct response. 8.49e+06. What is the difference between the Aid flow (current US$) in Maldives in 1998 and the Aid flow (current US$) in Mali in 1999?
Give a very brief answer. -2.31e+07. What is the difference between the Aid flow (current US$) of Maldives in 1998 and the Aid flow (current US$) of Swaziland in 1999?
Your answer should be compact. -8.85e+06. What is the difference between the Aid flow (current US$) of Mali in 1998 and the Aid flow (current US$) of Swaziland in 1999?
Offer a very short reply. 2.66e+07. What is the difference between the Aid flow (current US$) in Barbados in 1998 and the Aid flow (current US$) in Maldives in 2000?
Your response must be concise. 1.72e+07. What is the difference between the Aid flow (current US$) of Barbados in 1998 and the Aid flow (current US$) of Mali in 2000?
Give a very brief answer. 7.80e+06. What is the difference between the Aid flow (current US$) of Barbados in 1998 and the Aid flow (current US$) of Swaziland in 2000?
Provide a short and direct response. 1.15e+07. What is the difference between the Aid flow (current US$) in Maldives in 1998 and the Aid flow (current US$) in Mali in 2000?
Keep it short and to the point. -9.54e+06. What is the difference between the Aid flow (current US$) in Maldives in 1998 and the Aid flow (current US$) in Swaziland in 2000?
Ensure brevity in your answer.  -5.86e+06. What is the difference between the Aid flow (current US$) of Mali in 1998 and the Aid flow (current US$) of Swaziland in 2000?
Your answer should be very brief. 2.96e+07. What is the difference between the Aid flow (current US$) in Maldives in 1999 and the Aid flow (current US$) in Mali in 2000?
Keep it short and to the point. -9.19e+06. What is the difference between the Aid flow (current US$) in Maldives in 1999 and the Aid flow (current US$) in Swaziland in 2000?
Ensure brevity in your answer.  -5.51e+06. What is the difference between the Aid flow (current US$) of Mali in 1999 and the Aid flow (current US$) of Swaziland in 2000?
Your answer should be compact. 1.73e+07. What is the average Aid flow (current US$) of Barbados per year?
Your response must be concise. 4.23e+06. What is the average Aid flow (current US$) of Maldives per year?
Provide a short and direct response. 4.52e+05. What is the average Aid flow (current US$) of Mali per year?
Keep it short and to the point. 4.90e+07. What is the average Aid flow (current US$) of Swaziland per year?
Your answer should be very brief. 7.67e+06. In the year 1992, what is the difference between the Aid flow (current US$) of Barbados and Aid flow (current US$) of Maldives?
Keep it short and to the point. 4.30e+05. In the year 1992, what is the difference between the Aid flow (current US$) in Barbados and Aid flow (current US$) in Mali?
Make the answer very short. -6.99e+07. In the year 1992, what is the difference between the Aid flow (current US$) of Barbados and Aid flow (current US$) of Swaziland?
Offer a very short reply. -7.07e+06. In the year 1992, what is the difference between the Aid flow (current US$) of Maldives and Aid flow (current US$) of Mali?
Provide a short and direct response. -7.04e+07. In the year 1992, what is the difference between the Aid flow (current US$) of Maldives and Aid flow (current US$) of Swaziland?
Make the answer very short. -7.50e+06. In the year 1992, what is the difference between the Aid flow (current US$) of Mali and Aid flow (current US$) of Swaziland?
Keep it short and to the point. 6.29e+07. In the year 1993, what is the difference between the Aid flow (current US$) of Barbados and Aid flow (current US$) of Maldives?
Make the answer very short. 5.55e+06. In the year 1993, what is the difference between the Aid flow (current US$) in Barbados and Aid flow (current US$) in Mali?
Make the answer very short. -5.25e+07. In the year 1993, what is the difference between the Aid flow (current US$) in Barbados and Aid flow (current US$) in Swaziland?
Ensure brevity in your answer.  8.60e+05. In the year 1993, what is the difference between the Aid flow (current US$) of Maldives and Aid flow (current US$) of Mali?
Keep it short and to the point. -5.81e+07. In the year 1993, what is the difference between the Aid flow (current US$) in Maldives and Aid flow (current US$) in Swaziland?
Keep it short and to the point. -4.69e+06. In the year 1993, what is the difference between the Aid flow (current US$) of Mali and Aid flow (current US$) of Swaziland?
Ensure brevity in your answer.  5.34e+07. In the year 1994, what is the difference between the Aid flow (current US$) of Barbados and Aid flow (current US$) of Maldives?
Offer a very short reply. 1.69e+06. In the year 1994, what is the difference between the Aid flow (current US$) of Barbados and Aid flow (current US$) of Mali?
Keep it short and to the point. -5.08e+07. In the year 1994, what is the difference between the Aid flow (current US$) of Barbados and Aid flow (current US$) of Swaziland?
Your answer should be very brief. -7.73e+06. In the year 1994, what is the difference between the Aid flow (current US$) of Maldives and Aid flow (current US$) of Mali?
Your answer should be compact. -5.24e+07. In the year 1994, what is the difference between the Aid flow (current US$) in Maldives and Aid flow (current US$) in Swaziland?
Your response must be concise. -9.42e+06. In the year 1994, what is the difference between the Aid flow (current US$) of Mali and Aid flow (current US$) of Swaziland?
Give a very brief answer. 4.30e+07. In the year 1995, what is the difference between the Aid flow (current US$) in Barbados and Aid flow (current US$) in Maldives?
Make the answer very short. -1.26e+06. In the year 1995, what is the difference between the Aid flow (current US$) of Barbados and Aid flow (current US$) of Mali?
Offer a terse response. -8.23e+07. In the year 1995, what is the difference between the Aid flow (current US$) of Barbados and Aid flow (current US$) of Swaziland?
Your answer should be compact. -7.18e+06. In the year 1995, what is the difference between the Aid flow (current US$) in Maldives and Aid flow (current US$) in Mali?
Make the answer very short. -8.10e+07. In the year 1995, what is the difference between the Aid flow (current US$) in Maldives and Aid flow (current US$) in Swaziland?
Keep it short and to the point. -5.92e+06. In the year 1995, what is the difference between the Aid flow (current US$) in Mali and Aid flow (current US$) in Swaziland?
Your answer should be very brief. 7.51e+07. In the year 1996, what is the difference between the Aid flow (current US$) of Barbados and Aid flow (current US$) of Maldives?
Your answer should be compact. 5.20e+06. In the year 1996, what is the difference between the Aid flow (current US$) of Barbados and Aid flow (current US$) of Mali?
Offer a very short reply. -5.37e+07. In the year 1996, what is the difference between the Aid flow (current US$) of Barbados and Aid flow (current US$) of Swaziland?
Make the answer very short. -2.81e+06. In the year 1996, what is the difference between the Aid flow (current US$) of Maldives and Aid flow (current US$) of Mali?
Provide a short and direct response. -5.89e+07. In the year 1996, what is the difference between the Aid flow (current US$) of Maldives and Aid flow (current US$) of Swaziland?
Make the answer very short. -8.01e+06. In the year 1996, what is the difference between the Aid flow (current US$) in Mali and Aid flow (current US$) in Swaziland?
Ensure brevity in your answer.  5.09e+07. In the year 1998, what is the difference between the Aid flow (current US$) in Barbados and Aid flow (current US$) in Maldives?
Keep it short and to the point. 1.73e+07. In the year 1998, what is the difference between the Aid flow (current US$) in Barbados and Aid flow (current US$) in Mali?
Offer a very short reply. -1.82e+07. In the year 1998, what is the difference between the Aid flow (current US$) of Barbados and Aid flow (current US$) of Swaziland?
Offer a very short reply. 9.34e+06. In the year 1998, what is the difference between the Aid flow (current US$) in Maldives and Aid flow (current US$) in Mali?
Your response must be concise. -3.55e+07. In the year 1998, what is the difference between the Aid flow (current US$) in Maldives and Aid flow (current US$) in Swaziland?
Provide a succinct answer. -8.00e+06. In the year 1998, what is the difference between the Aid flow (current US$) of Mali and Aid flow (current US$) of Swaziland?
Offer a very short reply. 2.75e+07. In the year 1999, what is the difference between the Aid flow (current US$) of Maldives and Aid flow (current US$) of Mali?
Keep it short and to the point. -2.28e+07. In the year 1999, what is the difference between the Aid flow (current US$) in Maldives and Aid flow (current US$) in Swaziland?
Provide a succinct answer. -8.50e+06. In the year 1999, what is the difference between the Aid flow (current US$) in Mali and Aid flow (current US$) in Swaziland?
Your response must be concise. 1.43e+07. In the year 2000, what is the difference between the Aid flow (current US$) in Barbados and Aid flow (current US$) in Maldives?
Your answer should be compact. 1.67e+06. In the year 2000, what is the difference between the Aid flow (current US$) in Barbados and Aid flow (current US$) in Mali?
Your response must be concise. -7.71e+06. In the year 2000, what is the difference between the Aid flow (current US$) of Barbados and Aid flow (current US$) of Swaziland?
Your answer should be compact. -4.03e+06. In the year 2000, what is the difference between the Aid flow (current US$) of Maldives and Aid flow (current US$) of Mali?
Your answer should be very brief. -9.38e+06. In the year 2000, what is the difference between the Aid flow (current US$) of Maldives and Aid flow (current US$) of Swaziland?
Provide a succinct answer. -5.70e+06. In the year 2000, what is the difference between the Aid flow (current US$) of Mali and Aid flow (current US$) of Swaziland?
Give a very brief answer. 3.68e+06. What is the ratio of the Aid flow (current US$) of Barbados in 1992 to that in 1993?
Your answer should be compact. 0.21. What is the ratio of the Aid flow (current US$) in Maldives in 1992 to that in 1993?
Your answer should be compact. 6.91. What is the ratio of the Aid flow (current US$) of Mali in 1992 to that in 1993?
Your response must be concise. 1.22. What is the ratio of the Aid flow (current US$) of Swaziland in 1992 to that in 1993?
Provide a short and direct response. 1.72. What is the ratio of the Aid flow (current US$) of Barbados in 1992 to that in 1994?
Make the answer very short. 0.61. What is the ratio of the Aid flow (current US$) in Maldives in 1992 to that in 1994?
Offer a very short reply. 2.92. What is the ratio of the Aid flow (current US$) of Mali in 1992 to that in 1994?
Make the answer very short. 1.35. What is the ratio of the Aid flow (current US$) of Swaziland in 1992 to that in 1994?
Your answer should be compact. 0.85. What is the ratio of the Aid flow (current US$) of Barbados in 1992 to that in 1995?
Your answer should be compact. 6.61. What is the ratio of the Aid flow (current US$) in Maldives in 1992 to that in 1995?
Make the answer very short. 0.53. What is the ratio of the Aid flow (current US$) of Mali in 1992 to that in 1995?
Provide a short and direct response. 0.86. What is the ratio of the Aid flow (current US$) of Swaziland in 1992 to that in 1995?
Make the answer very short. 1.12. What is the ratio of the Aid flow (current US$) of Barbados in 1992 to that in 1996?
Offer a very short reply. 0.21. What is the ratio of the Aid flow (current US$) of Maldives in 1992 to that in 1996?
Your answer should be compact. 1.58. What is the ratio of the Aid flow (current US$) of Mali in 1992 to that in 1996?
Give a very brief answer. 1.2. What is the ratio of the Aid flow (current US$) of Swaziland in 1992 to that in 1996?
Keep it short and to the point. 0.97. What is the ratio of the Aid flow (current US$) in Barbados in 1992 to that in 1998?
Provide a short and direct response. 0.07. What is the ratio of the Aid flow (current US$) in Maldives in 1992 to that in 1998?
Your response must be concise. 38. What is the ratio of the Aid flow (current US$) of Mali in 1992 to that in 1998?
Give a very brief answer. 2. What is the ratio of the Aid flow (current US$) of Swaziland in 1992 to that in 1998?
Provide a short and direct response. 1.03. What is the ratio of the Aid flow (current US$) of Maldives in 1992 to that in 1999?
Give a very brief answer. 2.05. What is the ratio of the Aid flow (current US$) in Mali in 1992 to that in 1999?
Provide a short and direct response. 3.07. What is the ratio of the Aid flow (current US$) of Swaziland in 1992 to that in 1999?
Your answer should be very brief. 0.93. What is the ratio of the Aid flow (current US$) of Barbados in 1992 to that in 2000?
Keep it short and to the point. 0.64. What is the ratio of the Aid flow (current US$) of Maldives in 1992 to that in 2000?
Ensure brevity in your answer.  4.22. What is the ratio of the Aid flow (current US$) of Mali in 1992 to that in 2000?
Ensure brevity in your answer.  7.44. What is the ratio of the Aid flow (current US$) in Swaziland in 1992 to that in 2000?
Provide a succinct answer. 1.4. What is the ratio of the Aid flow (current US$) of Barbados in 1993 to that in 1994?
Offer a very short reply. 2.9. What is the ratio of the Aid flow (current US$) of Maldives in 1993 to that in 1994?
Keep it short and to the point. 0.42. What is the ratio of the Aid flow (current US$) in Mali in 1993 to that in 1994?
Give a very brief answer. 1.1. What is the ratio of the Aid flow (current US$) of Swaziland in 1993 to that in 1994?
Provide a succinct answer. 0.5. What is the ratio of the Aid flow (current US$) in Barbados in 1993 to that in 1995?
Offer a terse response. 31.44. What is the ratio of the Aid flow (current US$) of Maldives in 1993 to that in 1995?
Give a very brief answer. 0.08. What is the ratio of the Aid flow (current US$) in Mali in 1993 to that in 1995?
Your response must be concise. 0.71. What is the ratio of the Aid flow (current US$) in Swaziland in 1993 to that in 1995?
Offer a very short reply. 0.65. What is the ratio of the Aid flow (current US$) of Maldives in 1993 to that in 1996?
Make the answer very short. 0.23. What is the ratio of the Aid flow (current US$) of Mali in 1993 to that in 1996?
Offer a very short reply. 0.98. What is the ratio of the Aid flow (current US$) in Swaziland in 1993 to that in 1996?
Your answer should be very brief. 0.57. What is the ratio of the Aid flow (current US$) of Barbados in 1993 to that in 1998?
Provide a succinct answer. 0.33. What is the ratio of the Aid flow (current US$) in Maldives in 1993 to that in 1998?
Offer a terse response. 5.5. What is the ratio of the Aid flow (current US$) of Mali in 1993 to that in 1998?
Make the answer very short. 1.64. What is the ratio of the Aid flow (current US$) of Swaziland in 1993 to that in 1998?
Make the answer very short. 0.6. What is the ratio of the Aid flow (current US$) of Maldives in 1993 to that in 1999?
Make the answer very short. 0.3. What is the ratio of the Aid flow (current US$) in Mali in 1993 to that in 1999?
Your response must be concise. 2.51. What is the ratio of the Aid flow (current US$) of Swaziland in 1993 to that in 1999?
Offer a terse response. 0.54. What is the ratio of the Aid flow (current US$) of Barbados in 1993 to that in 2000?
Your answer should be very brief. 3.06. What is the ratio of the Aid flow (current US$) of Maldives in 1993 to that in 2000?
Keep it short and to the point. 0.61. What is the ratio of the Aid flow (current US$) in Mali in 1993 to that in 2000?
Your answer should be very brief. 6.08. What is the ratio of the Aid flow (current US$) of Swaziland in 1993 to that in 2000?
Provide a short and direct response. 0.82. What is the ratio of the Aid flow (current US$) in Barbados in 1994 to that in 1995?
Keep it short and to the point. 10.83. What is the ratio of the Aid flow (current US$) in Maldives in 1994 to that in 1995?
Give a very brief answer. 0.18. What is the ratio of the Aid flow (current US$) of Mali in 1994 to that in 1995?
Provide a short and direct response. 0.64. What is the ratio of the Aid flow (current US$) in Swaziland in 1994 to that in 1995?
Make the answer very short. 1.32. What is the ratio of the Aid flow (current US$) in Barbados in 1994 to that in 1996?
Your answer should be compact. 0.34. What is the ratio of the Aid flow (current US$) of Maldives in 1994 to that in 1996?
Ensure brevity in your answer.  0.54. What is the ratio of the Aid flow (current US$) of Mali in 1994 to that in 1996?
Keep it short and to the point. 0.89. What is the ratio of the Aid flow (current US$) of Swaziland in 1994 to that in 1996?
Provide a short and direct response. 1.14. What is the ratio of the Aid flow (current US$) of Barbados in 1994 to that in 1998?
Provide a succinct answer. 0.11. What is the ratio of the Aid flow (current US$) of Mali in 1994 to that in 1998?
Your answer should be compact. 1.48. What is the ratio of the Aid flow (current US$) in Swaziland in 1994 to that in 1998?
Your answer should be compact. 1.21. What is the ratio of the Aid flow (current US$) of Maldives in 1994 to that in 1999?
Your response must be concise. 0.7. What is the ratio of the Aid flow (current US$) of Mali in 1994 to that in 1999?
Make the answer very short. 2.28. What is the ratio of the Aid flow (current US$) of Swaziland in 1994 to that in 1999?
Provide a short and direct response. 1.09. What is the ratio of the Aid flow (current US$) in Barbados in 1994 to that in 2000?
Offer a terse response. 1.05. What is the ratio of the Aid flow (current US$) of Maldives in 1994 to that in 2000?
Your answer should be compact. 1.44. What is the ratio of the Aid flow (current US$) in Mali in 1994 to that in 2000?
Make the answer very short. 5.51. What is the ratio of the Aid flow (current US$) in Swaziland in 1994 to that in 2000?
Provide a short and direct response. 1.65. What is the ratio of the Aid flow (current US$) in Barbados in 1995 to that in 1996?
Your answer should be very brief. 0.03. What is the ratio of the Aid flow (current US$) in Mali in 1995 to that in 1996?
Offer a terse response. 1.39. What is the ratio of the Aid flow (current US$) in Swaziland in 1995 to that in 1996?
Provide a succinct answer. 0.87. What is the ratio of the Aid flow (current US$) in Barbados in 1995 to that in 1998?
Offer a terse response. 0.01. What is the ratio of the Aid flow (current US$) in Mali in 1995 to that in 1998?
Keep it short and to the point. 2.32. What is the ratio of the Aid flow (current US$) in Swaziland in 1995 to that in 1998?
Provide a short and direct response. 0.92. What is the ratio of the Aid flow (current US$) of Maldives in 1995 to that in 1999?
Your answer should be very brief. 3.89. What is the ratio of the Aid flow (current US$) of Mali in 1995 to that in 1999?
Offer a very short reply. 3.56. What is the ratio of the Aid flow (current US$) in Swaziland in 1995 to that in 1999?
Your answer should be compact. 0.83. What is the ratio of the Aid flow (current US$) in Barbados in 1995 to that in 2000?
Provide a succinct answer. 0.1. What is the ratio of the Aid flow (current US$) in Maldives in 1995 to that in 2000?
Offer a terse response. 8. What is the ratio of the Aid flow (current US$) of Mali in 1995 to that in 2000?
Make the answer very short. 8.63. What is the ratio of the Aid flow (current US$) of Swaziland in 1995 to that in 2000?
Your response must be concise. 1.25. What is the ratio of the Aid flow (current US$) in Barbados in 1996 to that in 1998?
Your response must be concise. 0.33. What is the ratio of the Aid flow (current US$) in Maldives in 1996 to that in 1998?
Offer a very short reply. 24. What is the ratio of the Aid flow (current US$) of Mali in 1996 to that in 1998?
Your answer should be very brief. 1.67. What is the ratio of the Aid flow (current US$) in Swaziland in 1996 to that in 1998?
Keep it short and to the point. 1.06. What is the ratio of the Aid flow (current US$) of Maldives in 1996 to that in 1999?
Your answer should be very brief. 1.3. What is the ratio of the Aid flow (current US$) in Mali in 1996 to that in 1999?
Your answer should be very brief. 2.57. What is the ratio of the Aid flow (current US$) of Swaziland in 1996 to that in 1999?
Provide a succinct answer. 0.96. What is the ratio of the Aid flow (current US$) in Barbados in 1996 to that in 2000?
Provide a succinct answer. 3.07. What is the ratio of the Aid flow (current US$) in Maldives in 1996 to that in 2000?
Provide a succinct answer. 2.67. What is the ratio of the Aid flow (current US$) in Mali in 1996 to that in 2000?
Your answer should be very brief. 6.21. What is the ratio of the Aid flow (current US$) in Swaziland in 1996 to that in 2000?
Keep it short and to the point. 1.44. What is the ratio of the Aid flow (current US$) in Maldives in 1998 to that in 1999?
Provide a succinct answer. 0.05. What is the ratio of the Aid flow (current US$) in Mali in 1998 to that in 1999?
Keep it short and to the point. 1.53. What is the ratio of the Aid flow (current US$) of Swaziland in 1998 to that in 1999?
Keep it short and to the point. 0.9. What is the ratio of the Aid flow (current US$) of Barbados in 1998 to that in 2000?
Offer a very short reply. 9.38. What is the ratio of the Aid flow (current US$) of Mali in 1998 to that in 2000?
Your answer should be compact. 3.71. What is the ratio of the Aid flow (current US$) of Swaziland in 1998 to that in 2000?
Your answer should be very brief. 1.36. What is the ratio of the Aid flow (current US$) in Maldives in 1999 to that in 2000?
Keep it short and to the point. 2.06. What is the ratio of the Aid flow (current US$) in Mali in 1999 to that in 2000?
Your answer should be compact. 2.42. What is the ratio of the Aid flow (current US$) of Swaziland in 1999 to that in 2000?
Make the answer very short. 1.51. What is the difference between the highest and the second highest Aid flow (current US$) in Barbados?
Provide a short and direct response. 1.17e+07. What is the difference between the highest and the second highest Aid flow (current US$) of Maldives?
Keep it short and to the point. 6.80e+05. What is the difference between the highest and the second highest Aid flow (current US$) of Mali?
Provide a short and direct response. 1.14e+07. What is the difference between the highest and the second highest Aid flow (current US$) in Swaziland?
Make the answer very short. 8.10e+05. What is the difference between the highest and the lowest Aid flow (current US$) of Barbados?
Your answer should be compact. 1.74e+07. What is the difference between the highest and the lowest Aid flow (current US$) in Maldives?
Your answer should be compact. 1.42e+06. What is the difference between the highest and the lowest Aid flow (current US$) in Mali?
Your answer should be compact. 7.29e+07. What is the difference between the highest and the lowest Aid flow (current US$) in Swaziland?
Your answer should be very brief. 4.88e+06. 